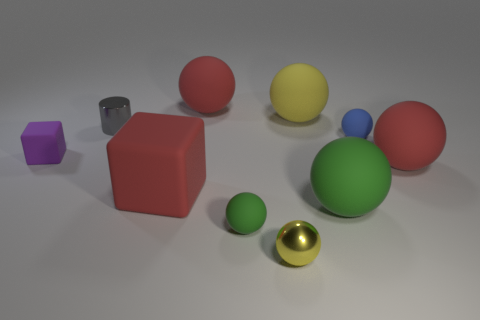There is another shiny object that is the same shape as the small green thing; what size is it?
Your answer should be compact. Small. What number of things are either matte spheres that are behind the large matte cube or metallic objects that are behind the tiny blue matte ball?
Offer a terse response. 5. Are there fewer spheres than rubber objects?
Keep it short and to the point. Yes. Does the yellow metallic ball have the same size as the metallic object behind the blue rubber object?
Your answer should be very brief. Yes. What number of shiny objects are either tiny gray things or green things?
Offer a very short reply. 1. Is the number of tiny purple things greater than the number of shiny objects?
Your answer should be very brief. No. What is the shape of the large red thing that is behind the red sphere that is to the right of the tiny blue rubber object?
Keep it short and to the point. Sphere. Are there any purple matte cubes that are to the left of the yellow object that is in front of the yellow matte sphere behind the tiny gray metal cylinder?
Provide a succinct answer. Yes. What is the color of the matte block that is the same size as the gray thing?
Offer a very short reply. Purple. There is a tiny thing that is in front of the large red rubber block and behind the tiny yellow metallic thing; what is its shape?
Provide a succinct answer. Sphere. 